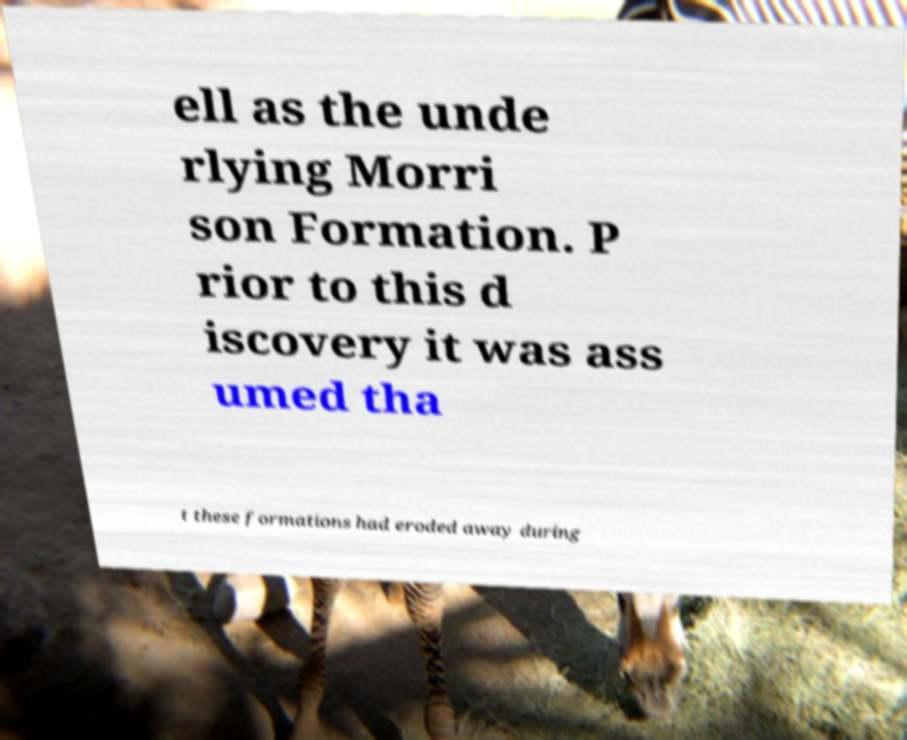Please read and relay the text visible in this image. What does it say? ell as the unde rlying Morri son Formation. P rior to this d iscovery it was ass umed tha t these formations had eroded away during 